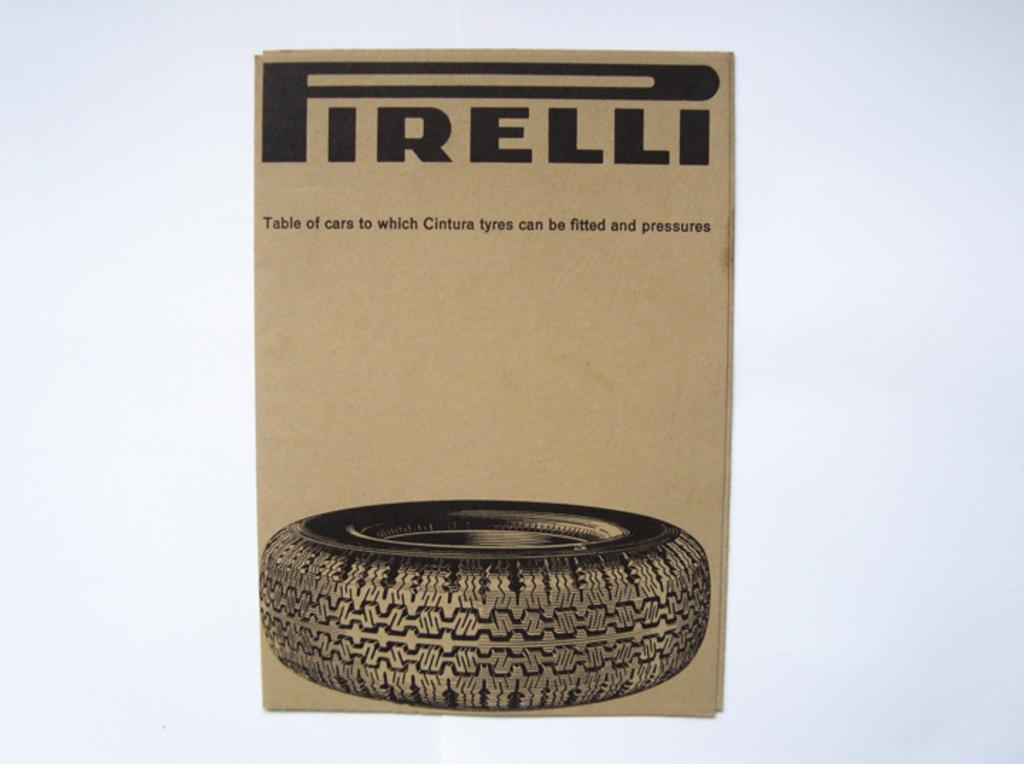What is one of the main objects in the image? There is a cardboard in the image. What other object can be seen in the image? There is a tire in the image. What is written or printed on the cardboard? There is text on the cardboard. Where is the park located in the image? There is no park present in the image. What type of chain can be seen connecting the cardboard and the tire? There is no chain present in the image. 